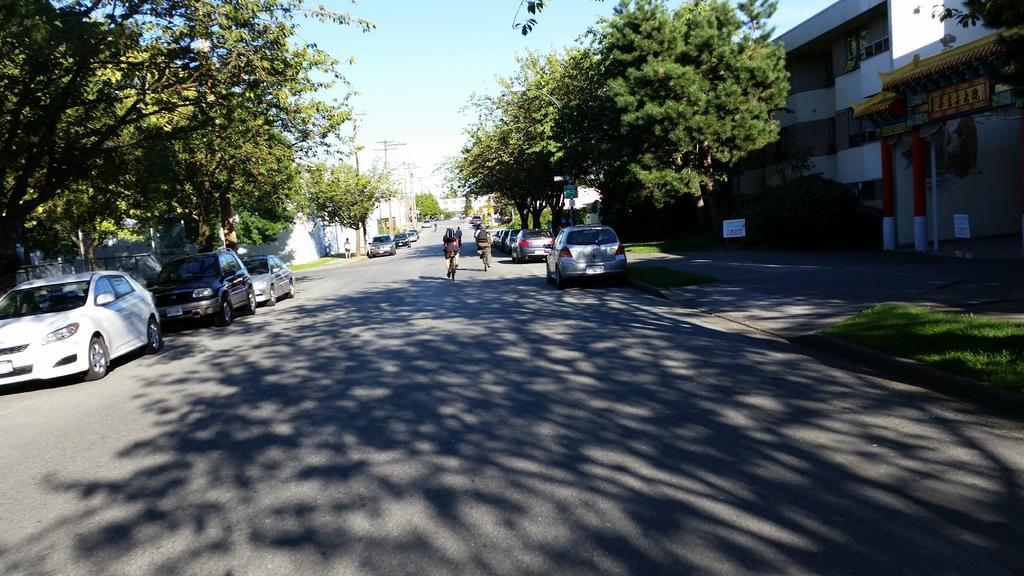Can you describe this image briefly? In this picture few people riding bicycles on the road and there is a person standing and we can see cars, trees, grass, arch, building, pillars and boards 